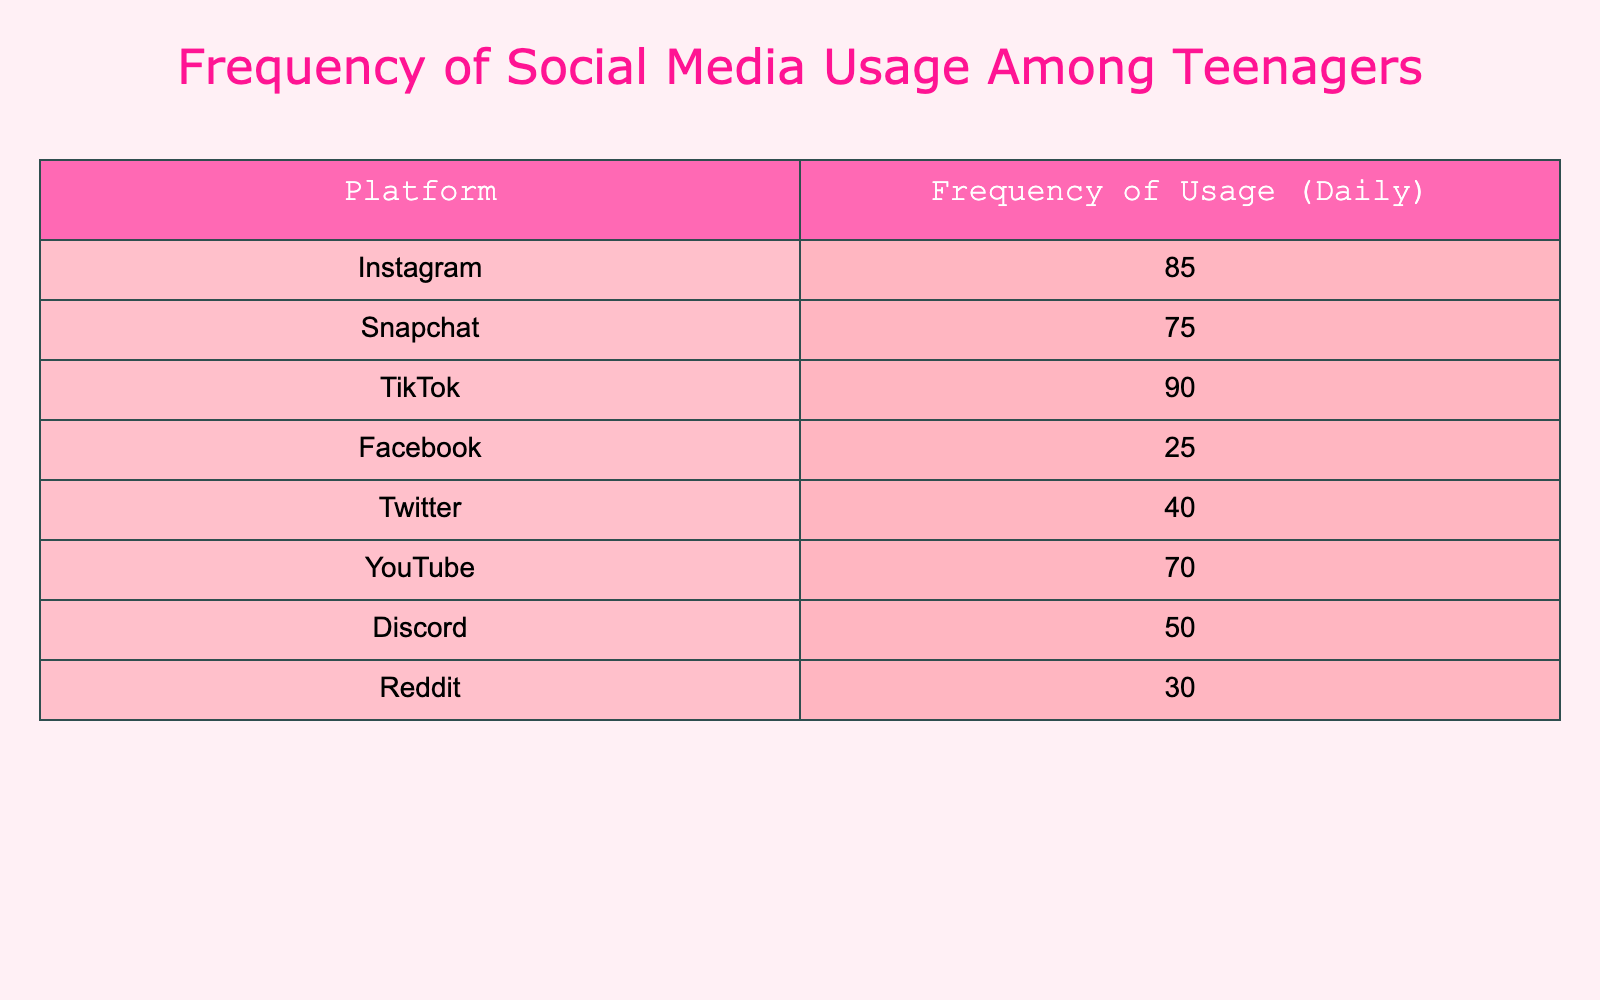What is the highest frequency of social media usage among teenagers? The table shows the frequency of usage for each platform. By comparing the values, TikTok has the highest frequency of usage at 90.
Answer: 90 Which social media platform has the lowest frequency of usage? Looking through the frequencies listed for each platform, Facebook has the lowest at 25.
Answer: Facebook What is the total frequency of usage for Instagram and Snapchat combined? To find the combined frequency, add both values together: Instagram (85) + Snapchat (75) = 160.
Answer: 160 Is the frequency of Twitter usage greater than that of YouTube? Twitter has a frequency of 40, while YouTube has 70. Since 40 is less than 70, the statement is false.
Answer: No What is the average frequency of social media usage across all platforms listed? First, sum all the frequencies: 85 + 75 + 90 + 25 + 40 + 70 + 50 + 30 = 465. There are 8 platforms, so the average is 465 / 8 = 58.125.
Answer: 58.125 How many platforms have a frequency of usage greater than 70? Looking at the table, TikTok (90) and Instagram (85) are the only platforms with frequencies above 70. So, the answer is 2.
Answer: 2 Which platforms have a frequency of usage that is less than 50? Checking the frequencies, Discord (50) is not less than 50, but Facebook (25) and Reddit (30) are both less than 50. Therefore, there are 2 platforms less than 50.
Answer: 2 What is the difference in frequency of usage between TikTok and Facebook? TikTok has a frequency of 90 and Facebook has a frequency of 25. The difference is calculated by subtracting the lower value from the higher value: 90 - 25 = 65.
Answer: 65 Are there any platforms with a frequency of usage between 40 and 70? Looking at the frequencies, we see Discord (50) and YouTube (70). Since 50 lies in the range and 70 is on the edge of the range, the answer is yes.
Answer: Yes 